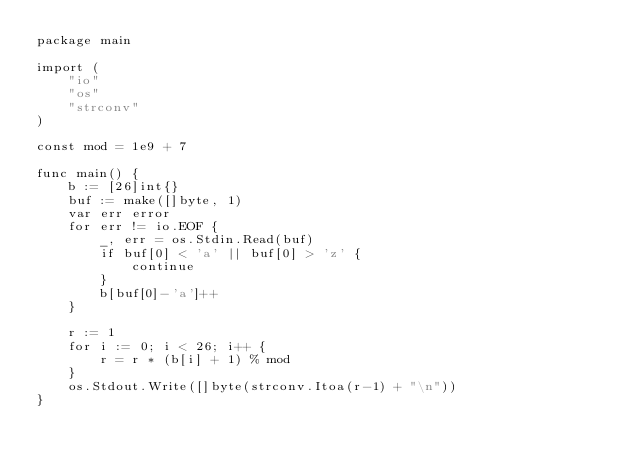Convert code to text. <code><loc_0><loc_0><loc_500><loc_500><_Go_>package main

import (
	"io"
	"os"
	"strconv"
)

const mod = 1e9 + 7

func main() {
	b := [26]int{}
	buf := make([]byte, 1)
	var err error
	for err != io.EOF {
		_, err = os.Stdin.Read(buf)
		if buf[0] < 'a' || buf[0] > 'z' {
			continue
		}
		b[buf[0]-'a']++
	}

	r := 1
	for i := 0; i < 26; i++ {
		r = r * (b[i] + 1) % mod
	}
	os.Stdout.Write([]byte(strconv.Itoa(r-1) + "\n"))
}</code> 